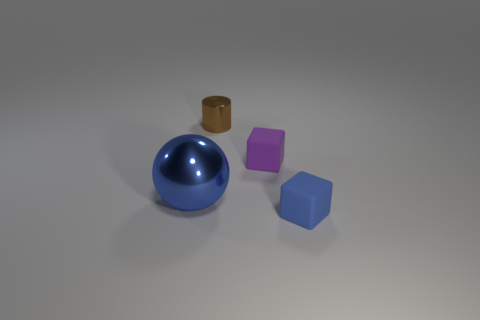Are there any tiny green metallic blocks? no 